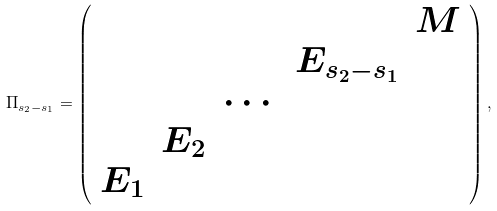Convert formula to latex. <formula><loc_0><loc_0><loc_500><loc_500>\Pi _ { s _ { 2 } - s _ { 1 } } = \left ( \begin{array} { c c c c c } & & & & M \\ & & & E _ { s _ { 2 } - s _ { 1 } } & \\ & & \cdots & & \\ & E _ { 2 } & & & \\ E _ { 1 } & & & & \end{array} \right ) ,</formula> 